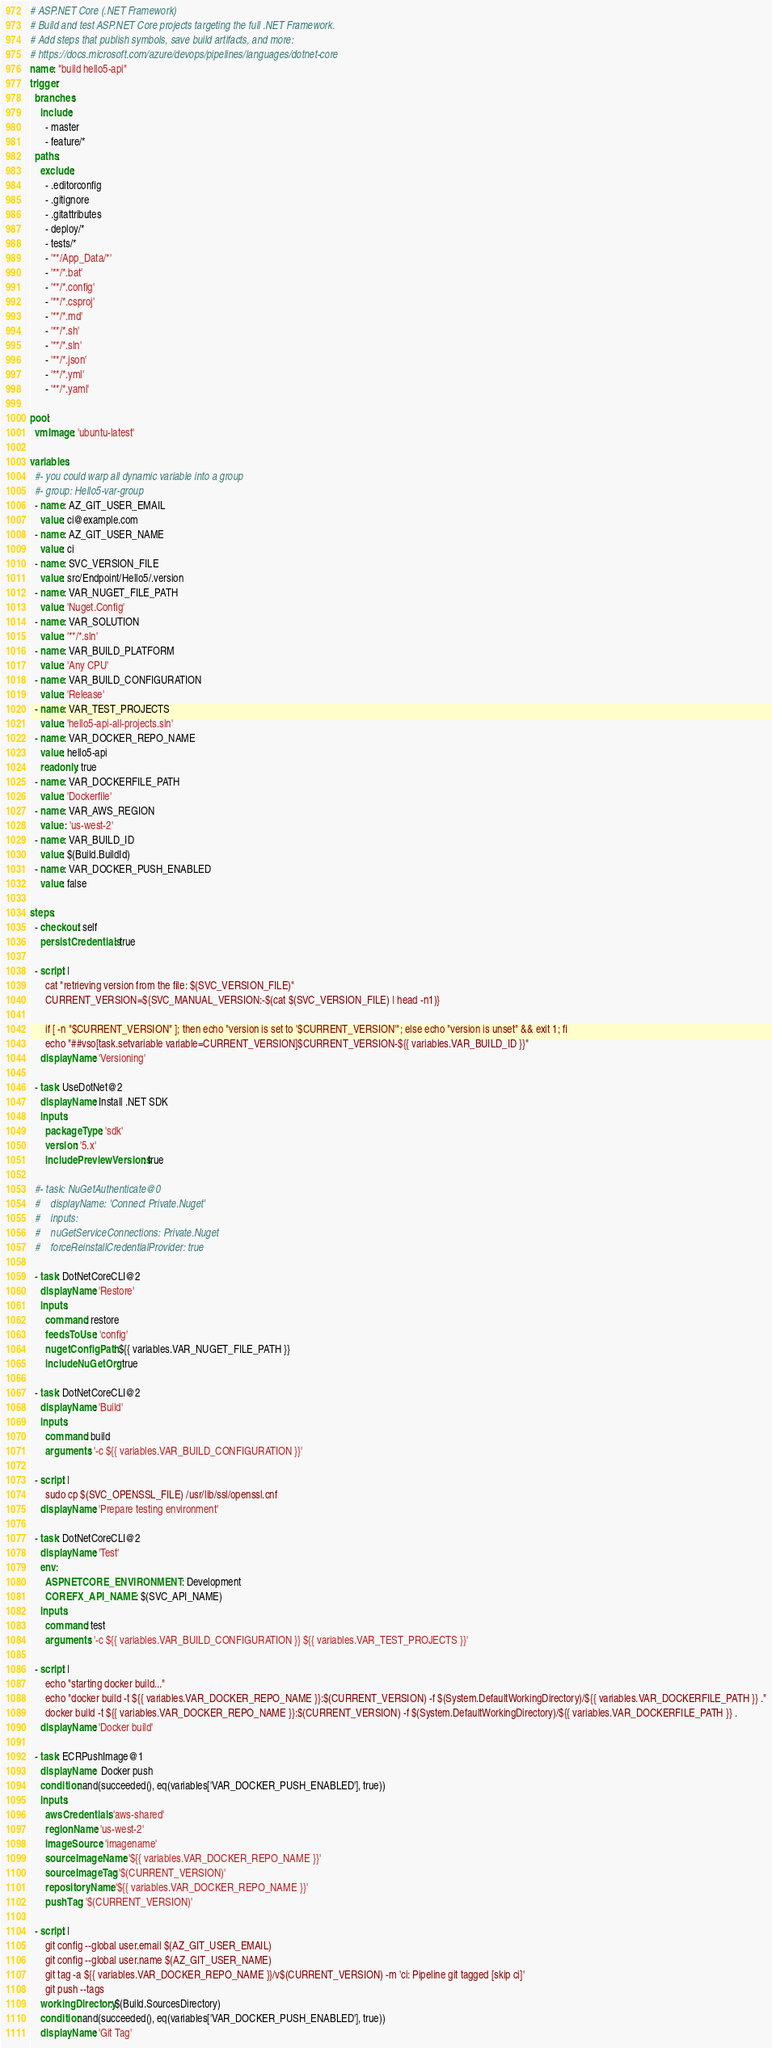<code> <loc_0><loc_0><loc_500><loc_500><_YAML_># ASP.NET Core (.NET Framework)
# Build and test ASP.NET Core projects targeting the full .NET Framework.
# Add steps that publish symbols, save build artifacts, and more:
# https://docs.microsoft.com/azure/devops/pipelines/languages/dotnet-core
name: "build hello5-api"
trigger:
  branches:
    include:
      - master
      - feature/*
  paths:
    exclude:
      - .editorconfig
      - .gitignore
      - .gitattributes
      - deploy/*
      - tests/*
      - '**/App_Data/*'
      - '**/*.bat'
      - '**/*.config'
      - '**/*.csproj'
      - '**/*.md'
      - '**/*.sh'
      - '**/*.sln'
      - '**/*.json'
      - '**/*.yml'
      - '**/*.yaml'

pool:
  vmImage: 'ubuntu-latest'

variables:
  #- you could warp all dynamic variable into a group
  #- group: Hello5-var-group
  - name: AZ_GIT_USER_EMAIL
    value: ci@example.com
  - name: AZ_GIT_USER_NAME
    value: ci
  - name: SVC_VERSION_FILE
    value: src/Endpoint/Hello5/.version    
  - name: VAR_NUGET_FILE_PATH
    value: 'Nuget.Config'
  - name: VAR_SOLUTION
    value: '**/*.sln'
  - name: VAR_BUILD_PLATFORM
    value: 'Any CPU'
  - name: VAR_BUILD_CONFIGURATION
    value: 'Release'
  - name: VAR_TEST_PROJECTS
    value: 'hello5-api-all-projects.sln'
  - name: VAR_DOCKER_REPO_NAME 
    value: hello5-api
    readonly: true
  - name: VAR_DOCKERFILE_PATH
    value: 'Dockerfile'
  - name: VAR_AWS_REGION
    value : 'us-west-2'
  - name: VAR_BUILD_ID
    value: $(Build.BuildId)
  - name: VAR_DOCKER_PUSH_ENABLED
    value: false

steps:
  - checkout: self
    persistCredentials: true

  - script: |
      cat "retrieving version from the file: $(SVC_VERSION_FILE)"
      CURRENT_VERSION=${SVC_MANUAL_VERSION:-$(cat $(SVC_VERSION_FILE) | head -n1)}

      if [ -n "$CURRENT_VERSION" ]; then echo "version is set to '$CURRENT_VERSION'"; else echo "version is unset" && exit 1; fi
      echo "##vso[task.setvariable variable=CURRENT_VERSION]$CURRENT_VERSION-${{ variables.VAR_BUILD_ID }}"
    displayName: 'Versioning'   

  - task: UseDotNet@2
    displayName: Install .NET SDK
    inputs:
      packageType: 'sdk'
      version: '5.x'
      includePreviewVersions: true

  #- task: NuGetAuthenticate@0
  #    displayName: 'Connect Private.Nuget'
  #    inputs:
  #    nuGetServiceConnections: Private.Nuget
  #    forceReinstallCredentialProvider: true

  - task: DotNetCoreCLI@2
    displayName: 'Restore'
    inputs:
      command: restore
      feedsToUse: 'config'
      nugetConfigPath: ${{ variables.VAR_NUGET_FILE_PATH }}
      includeNuGetOrg: true

  - task: DotNetCoreCLI@2
    displayName: 'Build'
    inputs:
      command: build
      arguments: '-c ${{ variables.VAR_BUILD_CONFIGURATION }}'
    
  - script: |
      sudo cp $(SVC_OPENSSL_FILE) /usr/lib/ssl/openssl.cnf
    displayName: 'Prepare testing environment'

  - task: DotNetCoreCLI@2
    displayName: 'Test'
    env:
      ASPNETCORE_ENVIRONMENT: Development
      COREFX_API_NAME: $(SVC_API_NAME)
    inputs:
      command: test
      arguments: '-c ${{ variables.VAR_BUILD_CONFIGURATION }} ${{ variables.VAR_TEST_PROJECTS }}'

  - script: |
      echo "starting docker build..."
      echo "docker build -t ${{ variables.VAR_DOCKER_REPO_NAME }}:$(CURRENT_VERSION) -f $(System.DefaultWorkingDirectory)/${{ variables.VAR_DOCKERFILE_PATH }} ."
      docker build -t ${{ variables.VAR_DOCKER_REPO_NAME }}:$(CURRENT_VERSION) -f $(System.DefaultWorkingDirectory)/${{ variables.VAR_DOCKERFILE_PATH }} .        
    displayName: 'Docker build' 
  
  - task: ECRPushImage@1
    displayName:  Docker push
    condition: and(succeeded(), eq(variables['VAR_DOCKER_PUSH_ENABLED'], true))
    inputs:
      awsCredentials: 'aws-shared'
      regionName: 'us-west-2'
      imageSource: 'imagename'
      sourceImageName: '${{ variables.VAR_DOCKER_REPO_NAME }}'
      sourceImageTag: '$(CURRENT_VERSION)'
      repositoryName: '${{ variables.VAR_DOCKER_REPO_NAME }}'
      pushTag: '$(CURRENT_VERSION)'

  - script: |
      git config --global user.email $(AZ_GIT_USER_EMAIL)
      git config --global user.name $(AZ_GIT_USER_NAME)
      git tag -a ${{ variables.VAR_DOCKER_REPO_NAME }}/v$(CURRENT_VERSION) -m 'ci: Pipeline git tagged [skip ci]' 
      git push --tags
    workingDirectory: $(Build.SourcesDirectory)
    condition: and(succeeded(), eq(variables['VAR_DOCKER_PUSH_ENABLED'], true))
    displayName: 'Git Tag'</code> 